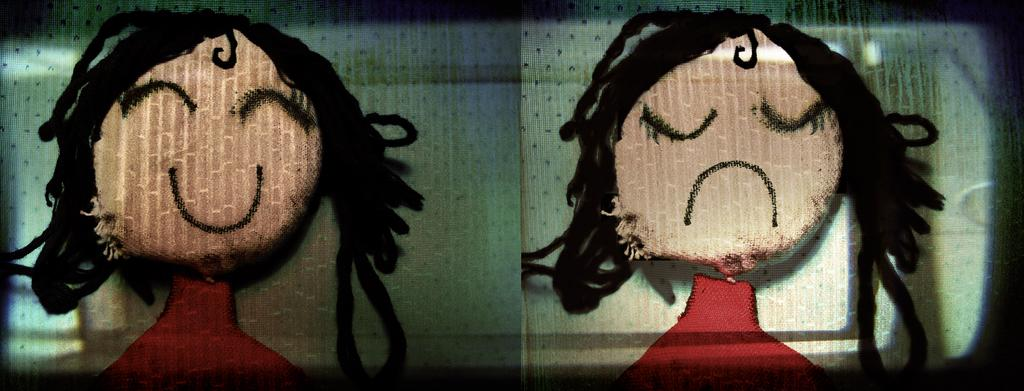What type of window covering is present in the image? There are sliding glasses in the image. What decorative elements can be seen on the sliding glasses? There is a painting on each sliding glass. What type of drug is being sold on the table in the image? There is no table or drug present in the image. Can you describe the snail crawling on the painting in the image? There is no snail present in the image; it only features sliding glasses with paintings on them. 